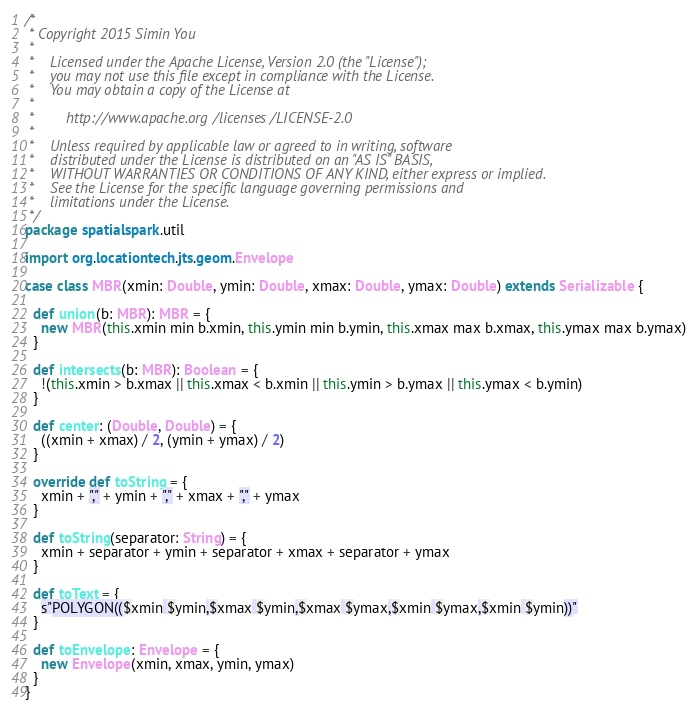<code> <loc_0><loc_0><loc_500><loc_500><_Scala_>/*
 * Copyright 2015 Simin You
 *
 *    Licensed under the Apache License, Version 2.0 (the "License");
 *    you may not use this file except in compliance with the License.
 *    You may obtain a copy of the License at
 *
 *        http://www.apache.org/licenses/LICENSE-2.0
 *
 *    Unless required by applicable law or agreed to in writing, software
 *    distributed under the License is distributed on an "AS IS" BASIS,
 *    WITHOUT WARRANTIES OR CONDITIONS OF ANY KIND, either express or implied.
 *    See the License for the specific language governing permissions and
 *    limitations under the License.
 */
package spatialspark.util

import org.locationtech.jts.geom.Envelope

case class MBR(xmin: Double, ymin: Double, xmax: Double, ymax: Double) extends Serializable {

  def union(b: MBR): MBR = {
    new MBR(this.xmin min b.xmin, this.ymin min b.ymin, this.xmax max b.xmax, this.ymax max b.ymax)
  }

  def intersects(b: MBR): Boolean = {
    !(this.xmin > b.xmax || this.xmax < b.xmin || this.ymin > b.ymax || this.ymax < b.ymin)
  }

  def center: (Double, Double) = {
    ((xmin + xmax) / 2, (ymin + ymax) / 2)
  }

  override def toString = {
    xmin + "," + ymin + "," + xmax + "," + ymax
  }

  def toString(separator: String) = {
    xmin + separator + ymin + separator + xmax + separator + ymax
  }

  def toText = {
    s"POLYGON(($xmin $ymin,$xmax $ymin,$xmax $ymax,$xmin $ymax,$xmin $ymin))"
  }

  def toEnvelope: Envelope = {
    new Envelope(xmin, xmax, ymin, ymax)
  }
}


</code> 